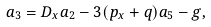<formula> <loc_0><loc_0><loc_500><loc_500>a _ { 3 } = D _ { x } a _ { 2 } - 3 ( p _ { x } + q ) a _ { 5 } - g ,</formula> 